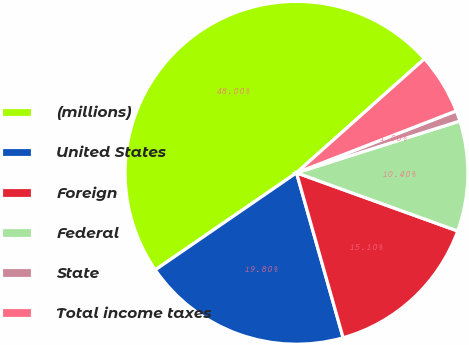Convert chart to OTSL. <chart><loc_0><loc_0><loc_500><loc_500><pie_chart><fcel>(millions)<fcel>United States<fcel>Foreign<fcel>Federal<fcel>State<fcel>Total income taxes<nl><fcel>48.0%<fcel>19.8%<fcel>15.1%<fcel>10.4%<fcel>1.0%<fcel>5.7%<nl></chart> 